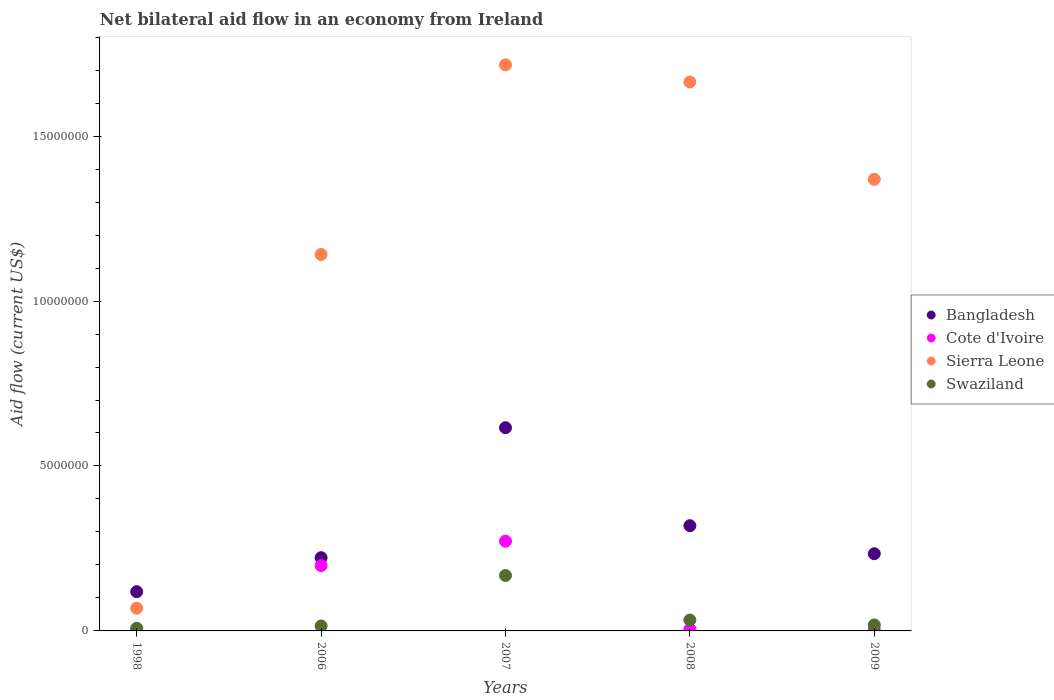Across all years, what is the maximum net bilateral aid flow in Sierra Leone?
Make the answer very short. 1.72e+07. What is the total net bilateral aid flow in Bangladesh in the graph?
Your answer should be very brief. 1.51e+07. What is the difference between the net bilateral aid flow in Swaziland in 2006 and that in 2007?
Your answer should be compact. -1.53e+06. What is the difference between the net bilateral aid flow in Bangladesh in 2007 and the net bilateral aid flow in Swaziland in 2008?
Offer a terse response. 5.83e+06. What is the average net bilateral aid flow in Sierra Leone per year?
Make the answer very short. 1.19e+07. In the year 2009, what is the difference between the net bilateral aid flow in Sierra Leone and net bilateral aid flow in Cote d'Ivoire?
Your answer should be very brief. 1.37e+07. In how many years, is the net bilateral aid flow in Cote d'Ivoire greater than 13000000 US$?
Your response must be concise. 0. What is the ratio of the net bilateral aid flow in Sierra Leone in 2008 to that in 2009?
Your response must be concise. 1.22. Is the difference between the net bilateral aid flow in Sierra Leone in 2007 and 2009 greater than the difference between the net bilateral aid flow in Cote d'Ivoire in 2007 and 2009?
Offer a terse response. Yes. What is the difference between the highest and the second highest net bilateral aid flow in Swaziland?
Your response must be concise. 1.35e+06. What is the difference between the highest and the lowest net bilateral aid flow in Sierra Leone?
Provide a succinct answer. 1.65e+07. In how many years, is the net bilateral aid flow in Bangladesh greater than the average net bilateral aid flow in Bangladesh taken over all years?
Ensure brevity in your answer.  2. Is the net bilateral aid flow in Swaziland strictly greater than the net bilateral aid flow in Bangladesh over the years?
Your answer should be very brief. No. Is the net bilateral aid flow in Sierra Leone strictly less than the net bilateral aid flow in Cote d'Ivoire over the years?
Make the answer very short. No. What is the difference between two consecutive major ticks on the Y-axis?
Make the answer very short. 5.00e+06. Are the values on the major ticks of Y-axis written in scientific E-notation?
Your answer should be compact. No. Does the graph contain grids?
Your response must be concise. No. How many legend labels are there?
Offer a very short reply. 4. How are the legend labels stacked?
Your response must be concise. Vertical. What is the title of the graph?
Provide a succinct answer. Net bilateral aid flow in an economy from Ireland. Does "Bulgaria" appear as one of the legend labels in the graph?
Ensure brevity in your answer.  No. What is the label or title of the Y-axis?
Offer a terse response. Aid flow (current US$). What is the Aid flow (current US$) of Bangladesh in 1998?
Make the answer very short. 1.19e+06. What is the Aid flow (current US$) of Cote d'Ivoire in 1998?
Your answer should be compact. 2.00e+04. What is the Aid flow (current US$) of Sierra Leone in 1998?
Your answer should be very brief. 6.90e+05. What is the Aid flow (current US$) in Bangladesh in 2006?
Your answer should be compact. 2.22e+06. What is the Aid flow (current US$) in Cote d'Ivoire in 2006?
Provide a short and direct response. 1.98e+06. What is the Aid flow (current US$) in Sierra Leone in 2006?
Your answer should be very brief. 1.14e+07. What is the Aid flow (current US$) in Swaziland in 2006?
Provide a short and direct response. 1.50e+05. What is the Aid flow (current US$) in Bangladesh in 2007?
Your answer should be compact. 6.16e+06. What is the Aid flow (current US$) of Cote d'Ivoire in 2007?
Ensure brevity in your answer.  2.72e+06. What is the Aid flow (current US$) in Sierra Leone in 2007?
Offer a very short reply. 1.72e+07. What is the Aid flow (current US$) of Swaziland in 2007?
Ensure brevity in your answer.  1.68e+06. What is the Aid flow (current US$) of Bangladesh in 2008?
Make the answer very short. 3.19e+06. What is the Aid flow (current US$) in Cote d'Ivoire in 2008?
Keep it short and to the point. 5.00e+04. What is the Aid flow (current US$) of Sierra Leone in 2008?
Make the answer very short. 1.66e+07. What is the Aid flow (current US$) of Bangladesh in 2009?
Keep it short and to the point. 2.34e+06. What is the Aid flow (current US$) in Cote d'Ivoire in 2009?
Offer a very short reply. 3.00e+04. What is the Aid flow (current US$) in Sierra Leone in 2009?
Offer a very short reply. 1.37e+07. Across all years, what is the maximum Aid flow (current US$) in Bangladesh?
Provide a succinct answer. 6.16e+06. Across all years, what is the maximum Aid flow (current US$) of Cote d'Ivoire?
Ensure brevity in your answer.  2.72e+06. Across all years, what is the maximum Aid flow (current US$) in Sierra Leone?
Ensure brevity in your answer.  1.72e+07. Across all years, what is the maximum Aid flow (current US$) of Swaziland?
Ensure brevity in your answer.  1.68e+06. Across all years, what is the minimum Aid flow (current US$) of Bangladesh?
Ensure brevity in your answer.  1.19e+06. Across all years, what is the minimum Aid flow (current US$) of Cote d'Ivoire?
Your answer should be very brief. 2.00e+04. Across all years, what is the minimum Aid flow (current US$) in Sierra Leone?
Ensure brevity in your answer.  6.90e+05. Across all years, what is the minimum Aid flow (current US$) in Swaziland?
Your answer should be very brief. 8.00e+04. What is the total Aid flow (current US$) of Bangladesh in the graph?
Your response must be concise. 1.51e+07. What is the total Aid flow (current US$) in Cote d'Ivoire in the graph?
Offer a terse response. 4.80e+06. What is the total Aid flow (current US$) in Sierra Leone in the graph?
Your answer should be compact. 5.96e+07. What is the total Aid flow (current US$) in Swaziland in the graph?
Your response must be concise. 2.42e+06. What is the difference between the Aid flow (current US$) of Bangladesh in 1998 and that in 2006?
Give a very brief answer. -1.03e+06. What is the difference between the Aid flow (current US$) of Cote d'Ivoire in 1998 and that in 2006?
Provide a short and direct response. -1.96e+06. What is the difference between the Aid flow (current US$) of Sierra Leone in 1998 and that in 2006?
Offer a very short reply. -1.07e+07. What is the difference between the Aid flow (current US$) of Bangladesh in 1998 and that in 2007?
Keep it short and to the point. -4.97e+06. What is the difference between the Aid flow (current US$) in Cote d'Ivoire in 1998 and that in 2007?
Ensure brevity in your answer.  -2.70e+06. What is the difference between the Aid flow (current US$) in Sierra Leone in 1998 and that in 2007?
Your response must be concise. -1.65e+07. What is the difference between the Aid flow (current US$) in Swaziland in 1998 and that in 2007?
Your answer should be compact. -1.60e+06. What is the difference between the Aid flow (current US$) of Bangladesh in 1998 and that in 2008?
Ensure brevity in your answer.  -2.00e+06. What is the difference between the Aid flow (current US$) of Sierra Leone in 1998 and that in 2008?
Keep it short and to the point. -1.60e+07. What is the difference between the Aid flow (current US$) in Bangladesh in 1998 and that in 2009?
Make the answer very short. -1.15e+06. What is the difference between the Aid flow (current US$) of Sierra Leone in 1998 and that in 2009?
Make the answer very short. -1.30e+07. What is the difference between the Aid flow (current US$) of Bangladesh in 2006 and that in 2007?
Make the answer very short. -3.94e+06. What is the difference between the Aid flow (current US$) of Cote d'Ivoire in 2006 and that in 2007?
Provide a short and direct response. -7.40e+05. What is the difference between the Aid flow (current US$) in Sierra Leone in 2006 and that in 2007?
Provide a succinct answer. -5.75e+06. What is the difference between the Aid flow (current US$) in Swaziland in 2006 and that in 2007?
Offer a terse response. -1.53e+06. What is the difference between the Aid flow (current US$) of Bangladesh in 2006 and that in 2008?
Offer a very short reply. -9.70e+05. What is the difference between the Aid flow (current US$) of Cote d'Ivoire in 2006 and that in 2008?
Make the answer very short. 1.93e+06. What is the difference between the Aid flow (current US$) in Sierra Leone in 2006 and that in 2008?
Your answer should be compact. -5.23e+06. What is the difference between the Aid flow (current US$) in Cote d'Ivoire in 2006 and that in 2009?
Offer a terse response. 1.95e+06. What is the difference between the Aid flow (current US$) in Sierra Leone in 2006 and that in 2009?
Ensure brevity in your answer.  -2.28e+06. What is the difference between the Aid flow (current US$) of Swaziland in 2006 and that in 2009?
Ensure brevity in your answer.  -3.00e+04. What is the difference between the Aid flow (current US$) of Bangladesh in 2007 and that in 2008?
Your response must be concise. 2.97e+06. What is the difference between the Aid flow (current US$) of Cote d'Ivoire in 2007 and that in 2008?
Provide a short and direct response. 2.67e+06. What is the difference between the Aid flow (current US$) in Sierra Leone in 2007 and that in 2008?
Your answer should be compact. 5.20e+05. What is the difference between the Aid flow (current US$) in Swaziland in 2007 and that in 2008?
Ensure brevity in your answer.  1.35e+06. What is the difference between the Aid flow (current US$) in Bangladesh in 2007 and that in 2009?
Your response must be concise. 3.82e+06. What is the difference between the Aid flow (current US$) of Cote d'Ivoire in 2007 and that in 2009?
Ensure brevity in your answer.  2.69e+06. What is the difference between the Aid flow (current US$) in Sierra Leone in 2007 and that in 2009?
Your answer should be very brief. 3.47e+06. What is the difference between the Aid flow (current US$) of Swaziland in 2007 and that in 2009?
Give a very brief answer. 1.50e+06. What is the difference between the Aid flow (current US$) in Bangladesh in 2008 and that in 2009?
Keep it short and to the point. 8.50e+05. What is the difference between the Aid flow (current US$) in Cote d'Ivoire in 2008 and that in 2009?
Ensure brevity in your answer.  2.00e+04. What is the difference between the Aid flow (current US$) in Sierra Leone in 2008 and that in 2009?
Provide a short and direct response. 2.95e+06. What is the difference between the Aid flow (current US$) in Bangladesh in 1998 and the Aid flow (current US$) in Cote d'Ivoire in 2006?
Provide a short and direct response. -7.90e+05. What is the difference between the Aid flow (current US$) of Bangladesh in 1998 and the Aid flow (current US$) of Sierra Leone in 2006?
Make the answer very short. -1.02e+07. What is the difference between the Aid flow (current US$) in Bangladesh in 1998 and the Aid flow (current US$) in Swaziland in 2006?
Your answer should be compact. 1.04e+06. What is the difference between the Aid flow (current US$) of Cote d'Ivoire in 1998 and the Aid flow (current US$) of Sierra Leone in 2006?
Offer a very short reply. -1.14e+07. What is the difference between the Aid flow (current US$) of Cote d'Ivoire in 1998 and the Aid flow (current US$) of Swaziland in 2006?
Ensure brevity in your answer.  -1.30e+05. What is the difference between the Aid flow (current US$) of Sierra Leone in 1998 and the Aid flow (current US$) of Swaziland in 2006?
Provide a short and direct response. 5.40e+05. What is the difference between the Aid flow (current US$) in Bangladesh in 1998 and the Aid flow (current US$) in Cote d'Ivoire in 2007?
Keep it short and to the point. -1.53e+06. What is the difference between the Aid flow (current US$) in Bangladesh in 1998 and the Aid flow (current US$) in Sierra Leone in 2007?
Give a very brief answer. -1.60e+07. What is the difference between the Aid flow (current US$) in Bangladesh in 1998 and the Aid flow (current US$) in Swaziland in 2007?
Ensure brevity in your answer.  -4.90e+05. What is the difference between the Aid flow (current US$) of Cote d'Ivoire in 1998 and the Aid flow (current US$) of Sierra Leone in 2007?
Your response must be concise. -1.71e+07. What is the difference between the Aid flow (current US$) in Cote d'Ivoire in 1998 and the Aid flow (current US$) in Swaziland in 2007?
Offer a terse response. -1.66e+06. What is the difference between the Aid flow (current US$) of Sierra Leone in 1998 and the Aid flow (current US$) of Swaziland in 2007?
Ensure brevity in your answer.  -9.90e+05. What is the difference between the Aid flow (current US$) in Bangladesh in 1998 and the Aid flow (current US$) in Cote d'Ivoire in 2008?
Offer a terse response. 1.14e+06. What is the difference between the Aid flow (current US$) of Bangladesh in 1998 and the Aid flow (current US$) of Sierra Leone in 2008?
Your response must be concise. -1.54e+07. What is the difference between the Aid flow (current US$) in Bangladesh in 1998 and the Aid flow (current US$) in Swaziland in 2008?
Make the answer very short. 8.60e+05. What is the difference between the Aid flow (current US$) of Cote d'Ivoire in 1998 and the Aid flow (current US$) of Sierra Leone in 2008?
Your response must be concise. -1.66e+07. What is the difference between the Aid flow (current US$) of Cote d'Ivoire in 1998 and the Aid flow (current US$) of Swaziland in 2008?
Your answer should be compact. -3.10e+05. What is the difference between the Aid flow (current US$) in Bangladesh in 1998 and the Aid flow (current US$) in Cote d'Ivoire in 2009?
Make the answer very short. 1.16e+06. What is the difference between the Aid flow (current US$) of Bangladesh in 1998 and the Aid flow (current US$) of Sierra Leone in 2009?
Make the answer very short. -1.25e+07. What is the difference between the Aid flow (current US$) of Bangladesh in 1998 and the Aid flow (current US$) of Swaziland in 2009?
Your answer should be compact. 1.01e+06. What is the difference between the Aid flow (current US$) in Cote d'Ivoire in 1998 and the Aid flow (current US$) in Sierra Leone in 2009?
Offer a very short reply. -1.37e+07. What is the difference between the Aid flow (current US$) of Sierra Leone in 1998 and the Aid flow (current US$) of Swaziland in 2009?
Offer a very short reply. 5.10e+05. What is the difference between the Aid flow (current US$) of Bangladesh in 2006 and the Aid flow (current US$) of Cote d'Ivoire in 2007?
Your response must be concise. -5.00e+05. What is the difference between the Aid flow (current US$) in Bangladesh in 2006 and the Aid flow (current US$) in Sierra Leone in 2007?
Give a very brief answer. -1.49e+07. What is the difference between the Aid flow (current US$) in Bangladesh in 2006 and the Aid flow (current US$) in Swaziland in 2007?
Give a very brief answer. 5.40e+05. What is the difference between the Aid flow (current US$) in Cote d'Ivoire in 2006 and the Aid flow (current US$) in Sierra Leone in 2007?
Provide a succinct answer. -1.52e+07. What is the difference between the Aid flow (current US$) in Sierra Leone in 2006 and the Aid flow (current US$) in Swaziland in 2007?
Provide a succinct answer. 9.73e+06. What is the difference between the Aid flow (current US$) in Bangladesh in 2006 and the Aid flow (current US$) in Cote d'Ivoire in 2008?
Ensure brevity in your answer.  2.17e+06. What is the difference between the Aid flow (current US$) of Bangladesh in 2006 and the Aid flow (current US$) of Sierra Leone in 2008?
Your response must be concise. -1.44e+07. What is the difference between the Aid flow (current US$) of Bangladesh in 2006 and the Aid flow (current US$) of Swaziland in 2008?
Give a very brief answer. 1.89e+06. What is the difference between the Aid flow (current US$) in Cote d'Ivoire in 2006 and the Aid flow (current US$) in Sierra Leone in 2008?
Offer a very short reply. -1.47e+07. What is the difference between the Aid flow (current US$) in Cote d'Ivoire in 2006 and the Aid flow (current US$) in Swaziland in 2008?
Provide a succinct answer. 1.65e+06. What is the difference between the Aid flow (current US$) in Sierra Leone in 2006 and the Aid flow (current US$) in Swaziland in 2008?
Make the answer very short. 1.11e+07. What is the difference between the Aid flow (current US$) in Bangladesh in 2006 and the Aid flow (current US$) in Cote d'Ivoire in 2009?
Ensure brevity in your answer.  2.19e+06. What is the difference between the Aid flow (current US$) of Bangladesh in 2006 and the Aid flow (current US$) of Sierra Leone in 2009?
Your answer should be compact. -1.15e+07. What is the difference between the Aid flow (current US$) in Bangladesh in 2006 and the Aid flow (current US$) in Swaziland in 2009?
Provide a short and direct response. 2.04e+06. What is the difference between the Aid flow (current US$) of Cote d'Ivoire in 2006 and the Aid flow (current US$) of Sierra Leone in 2009?
Provide a short and direct response. -1.17e+07. What is the difference between the Aid flow (current US$) in Cote d'Ivoire in 2006 and the Aid flow (current US$) in Swaziland in 2009?
Ensure brevity in your answer.  1.80e+06. What is the difference between the Aid flow (current US$) of Sierra Leone in 2006 and the Aid flow (current US$) of Swaziland in 2009?
Make the answer very short. 1.12e+07. What is the difference between the Aid flow (current US$) in Bangladesh in 2007 and the Aid flow (current US$) in Cote d'Ivoire in 2008?
Your response must be concise. 6.11e+06. What is the difference between the Aid flow (current US$) in Bangladesh in 2007 and the Aid flow (current US$) in Sierra Leone in 2008?
Offer a terse response. -1.05e+07. What is the difference between the Aid flow (current US$) in Bangladesh in 2007 and the Aid flow (current US$) in Swaziland in 2008?
Provide a short and direct response. 5.83e+06. What is the difference between the Aid flow (current US$) of Cote d'Ivoire in 2007 and the Aid flow (current US$) of Sierra Leone in 2008?
Keep it short and to the point. -1.39e+07. What is the difference between the Aid flow (current US$) of Cote d'Ivoire in 2007 and the Aid flow (current US$) of Swaziland in 2008?
Keep it short and to the point. 2.39e+06. What is the difference between the Aid flow (current US$) in Sierra Leone in 2007 and the Aid flow (current US$) in Swaziland in 2008?
Your response must be concise. 1.68e+07. What is the difference between the Aid flow (current US$) in Bangladesh in 2007 and the Aid flow (current US$) in Cote d'Ivoire in 2009?
Offer a very short reply. 6.13e+06. What is the difference between the Aid flow (current US$) in Bangladesh in 2007 and the Aid flow (current US$) in Sierra Leone in 2009?
Your response must be concise. -7.53e+06. What is the difference between the Aid flow (current US$) in Bangladesh in 2007 and the Aid flow (current US$) in Swaziland in 2009?
Ensure brevity in your answer.  5.98e+06. What is the difference between the Aid flow (current US$) in Cote d'Ivoire in 2007 and the Aid flow (current US$) in Sierra Leone in 2009?
Your answer should be compact. -1.10e+07. What is the difference between the Aid flow (current US$) of Cote d'Ivoire in 2007 and the Aid flow (current US$) of Swaziland in 2009?
Give a very brief answer. 2.54e+06. What is the difference between the Aid flow (current US$) in Sierra Leone in 2007 and the Aid flow (current US$) in Swaziland in 2009?
Keep it short and to the point. 1.70e+07. What is the difference between the Aid flow (current US$) in Bangladesh in 2008 and the Aid flow (current US$) in Cote d'Ivoire in 2009?
Provide a succinct answer. 3.16e+06. What is the difference between the Aid flow (current US$) in Bangladesh in 2008 and the Aid flow (current US$) in Sierra Leone in 2009?
Offer a very short reply. -1.05e+07. What is the difference between the Aid flow (current US$) in Bangladesh in 2008 and the Aid flow (current US$) in Swaziland in 2009?
Keep it short and to the point. 3.01e+06. What is the difference between the Aid flow (current US$) of Cote d'Ivoire in 2008 and the Aid flow (current US$) of Sierra Leone in 2009?
Your answer should be compact. -1.36e+07. What is the difference between the Aid flow (current US$) of Sierra Leone in 2008 and the Aid flow (current US$) of Swaziland in 2009?
Ensure brevity in your answer.  1.65e+07. What is the average Aid flow (current US$) in Bangladesh per year?
Give a very brief answer. 3.02e+06. What is the average Aid flow (current US$) of Cote d'Ivoire per year?
Keep it short and to the point. 9.60e+05. What is the average Aid flow (current US$) of Sierra Leone per year?
Offer a terse response. 1.19e+07. What is the average Aid flow (current US$) in Swaziland per year?
Your answer should be very brief. 4.84e+05. In the year 1998, what is the difference between the Aid flow (current US$) in Bangladesh and Aid flow (current US$) in Cote d'Ivoire?
Your answer should be compact. 1.17e+06. In the year 1998, what is the difference between the Aid flow (current US$) of Bangladesh and Aid flow (current US$) of Sierra Leone?
Give a very brief answer. 5.00e+05. In the year 1998, what is the difference between the Aid flow (current US$) in Bangladesh and Aid flow (current US$) in Swaziland?
Provide a short and direct response. 1.11e+06. In the year 1998, what is the difference between the Aid flow (current US$) of Cote d'Ivoire and Aid flow (current US$) of Sierra Leone?
Offer a terse response. -6.70e+05. In the year 2006, what is the difference between the Aid flow (current US$) of Bangladesh and Aid flow (current US$) of Cote d'Ivoire?
Make the answer very short. 2.40e+05. In the year 2006, what is the difference between the Aid flow (current US$) of Bangladesh and Aid flow (current US$) of Sierra Leone?
Provide a short and direct response. -9.19e+06. In the year 2006, what is the difference between the Aid flow (current US$) in Bangladesh and Aid flow (current US$) in Swaziland?
Offer a very short reply. 2.07e+06. In the year 2006, what is the difference between the Aid flow (current US$) in Cote d'Ivoire and Aid flow (current US$) in Sierra Leone?
Give a very brief answer. -9.43e+06. In the year 2006, what is the difference between the Aid flow (current US$) in Cote d'Ivoire and Aid flow (current US$) in Swaziland?
Your answer should be compact. 1.83e+06. In the year 2006, what is the difference between the Aid flow (current US$) of Sierra Leone and Aid flow (current US$) of Swaziland?
Make the answer very short. 1.13e+07. In the year 2007, what is the difference between the Aid flow (current US$) in Bangladesh and Aid flow (current US$) in Cote d'Ivoire?
Your answer should be compact. 3.44e+06. In the year 2007, what is the difference between the Aid flow (current US$) of Bangladesh and Aid flow (current US$) of Sierra Leone?
Make the answer very short. -1.10e+07. In the year 2007, what is the difference between the Aid flow (current US$) in Bangladesh and Aid flow (current US$) in Swaziland?
Make the answer very short. 4.48e+06. In the year 2007, what is the difference between the Aid flow (current US$) in Cote d'Ivoire and Aid flow (current US$) in Sierra Leone?
Your answer should be very brief. -1.44e+07. In the year 2007, what is the difference between the Aid flow (current US$) in Cote d'Ivoire and Aid flow (current US$) in Swaziland?
Give a very brief answer. 1.04e+06. In the year 2007, what is the difference between the Aid flow (current US$) in Sierra Leone and Aid flow (current US$) in Swaziland?
Offer a terse response. 1.55e+07. In the year 2008, what is the difference between the Aid flow (current US$) in Bangladesh and Aid flow (current US$) in Cote d'Ivoire?
Keep it short and to the point. 3.14e+06. In the year 2008, what is the difference between the Aid flow (current US$) in Bangladesh and Aid flow (current US$) in Sierra Leone?
Offer a very short reply. -1.34e+07. In the year 2008, what is the difference between the Aid flow (current US$) in Bangladesh and Aid flow (current US$) in Swaziland?
Your answer should be compact. 2.86e+06. In the year 2008, what is the difference between the Aid flow (current US$) of Cote d'Ivoire and Aid flow (current US$) of Sierra Leone?
Provide a short and direct response. -1.66e+07. In the year 2008, what is the difference between the Aid flow (current US$) of Cote d'Ivoire and Aid flow (current US$) of Swaziland?
Offer a terse response. -2.80e+05. In the year 2008, what is the difference between the Aid flow (current US$) in Sierra Leone and Aid flow (current US$) in Swaziland?
Ensure brevity in your answer.  1.63e+07. In the year 2009, what is the difference between the Aid flow (current US$) in Bangladesh and Aid flow (current US$) in Cote d'Ivoire?
Ensure brevity in your answer.  2.31e+06. In the year 2009, what is the difference between the Aid flow (current US$) of Bangladesh and Aid flow (current US$) of Sierra Leone?
Your answer should be very brief. -1.14e+07. In the year 2009, what is the difference between the Aid flow (current US$) of Bangladesh and Aid flow (current US$) of Swaziland?
Provide a short and direct response. 2.16e+06. In the year 2009, what is the difference between the Aid flow (current US$) of Cote d'Ivoire and Aid flow (current US$) of Sierra Leone?
Provide a short and direct response. -1.37e+07. In the year 2009, what is the difference between the Aid flow (current US$) in Cote d'Ivoire and Aid flow (current US$) in Swaziland?
Make the answer very short. -1.50e+05. In the year 2009, what is the difference between the Aid flow (current US$) of Sierra Leone and Aid flow (current US$) of Swaziland?
Your answer should be compact. 1.35e+07. What is the ratio of the Aid flow (current US$) of Bangladesh in 1998 to that in 2006?
Keep it short and to the point. 0.54. What is the ratio of the Aid flow (current US$) of Cote d'Ivoire in 1998 to that in 2006?
Give a very brief answer. 0.01. What is the ratio of the Aid flow (current US$) of Sierra Leone in 1998 to that in 2006?
Your answer should be very brief. 0.06. What is the ratio of the Aid flow (current US$) of Swaziland in 1998 to that in 2006?
Your response must be concise. 0.53. What is the ratio of the Aid flow (current US$) of Bangladesh in 1998 to that in 2007?
Make the answer very short. 0.19. What is the ratio of the Aid flow (current US$) of Cote d'Ivoire in 1998 to that in 2007?
Give a very brief answer. 0.01. What is the ratio of the Aid flow (current US$) in Sierra Leone in 1998 to that in 2007?
Provide a short and direct response. 0.04. What is the ratio of the Aid flow (current US$) of Swaziland in 1998 to that in 2007?
Keep it short and to the point. 0.05. What is the ratio of the Aid flow (current US$) of Bangladesh in 1998 to that in 2008?
Offer a very short reply. 0.37. What is the ratio of the Aid flow (current US$) in Cote d'Ivoire in 1998 to that in 2008?
Keep it short and to the point. 0.4. What is the ratio of the Aid flow (current US$) of Sierra Leone in 1998 to that in 2008?
Keep it short and to the point. 0.04. What is the ratio of the Aid flow (current US$) in Swaziland in 1998 to that in 2008?
Provide a short and direct response. 0.24. What is the ratio of the Aid flow (current US$) in Bangladesh in 1998 to that in 2009?
Offer a terse response. 0.51. What is the ratio of the Aid flow (current US$) of Cote d'Ivoire in 1998 to that in 2009?
Keep it short and to the point. 0.67. What is the ratio of the Aid flow (current US$) of Sierra Leone in 1998 to that in 2009?
Your answer should be compact. 0.05. What is the ratio of the Aid flow (current US$) of Swaziland in 1998 to that in 2009?
Make the answer very short. 0.44. What is the ratio of the Aid flow (current US$) in Bangladesh in 2006 to that in 2007?
Offer a very short reply. 0.36. What is the ratio of the Aid flow (current US$) of Cote d'Ivoire in 2006 to that in 2007?
Provide a short and direct response. 0.73. What is the ratio of the Aid flow (current US$) in Sierra Leone in 2006 to that in 2007?
Provide a short and direct response. 0.66. What is the ratio of the Aid flow (current US$) in Swaziland in 2006 to that in 2007?
Ensure brevity in your answer.  0.09. What is the ratio of the Aid flow (current US$) of Bangladesh in 2006 to that in 2008?
Offer a terse response. 0.7. What is the ratio of the Aid flow (current US$) of Cote d'Ivoire in 2006 to that in 2008?
Provide a short and direct response. 39.6. What is the ratio of the Aid flow (current US$) of Sierra Leone in 2006 to that in 2008?
Your answer should be very brief. 0.69. What is the ratio of the Aid flow (current US$) of Swaziland in 2006 to that in 2008?
Give a very brief answer. 0.45. What is the ratio of the Aid flow (current US$) of Bangladesh in 2006 to that in 2009?
Make the answer very short. 0.95. What is the ratio of the Aid flow (current US$) of Sierra Leone in 2006 to that in 2009?
Provide a succinct answer. 0.83. What is the ratio of the Aid flow (current US$) of Swaziland in 2006 to that in 2009?
Your answer should be compact. 0.83. What is the ratio of the Aid flow (current US$) of Bangladesh in 2007 to that in 2008?
Give a very brief answer. 1.93. What is the ratio of the Aid flow (current US$) in Cote d'Ivoire in 2007 to that in 2008?
Keep it short and to the point. 54.4. What is the ratio of the Aid flow (current US$) in Sierra Leone in 2007 to that in 2008?
Your answer should be very brief. 1.03. What is the ratio of the Aid flow (current US$) in Swaziland in 2007 to that in 2008?
Make the answer very short. 5.09. What is the ratio of the Aid flow (current US$) of Bangladesh in 2007 to that in 2009?
Your response must be concise. 2.63. What is the ratio of the Aid flow (current US$) of Cote d'Ivoire in 2007 to that in 2009?
Offer a very short reply. 90.67. What is the ratio of the Aid flow (current US$) of Sierra Leone in 2007 to that in 2009?
Offer a very short reply. 1.25. What is the ratio of the Aid flow (current US$) in Swaziland in 2007 to that in 2009?
Give a very brief answer. 9.33. What is the ratio of the Aid flow (current US$) in Bangladesh in 2008 to that in 2009?
Your answer should be compact. 1.36. What is the ratio of the Aid flow (current US$) in Sierra Leone in 2008 to that in 2009?
Your answer should be compact. 1.22. What is the ratio of the Aid flow (current US$) in Swaziland in 2008 to that in 2009?
Provide a short and direct response. 1.83. What is the difference between the highest and the second highest Aid flow (current US$) in Bangladesh?
Your answer should be very brief. 2.97e+06. What is the difference between the highest and the second highest Aid flow (current US$) in Cote d'Ivoire?
Your response must be concise. 7.40e+05. What is the difference between the highest and the second highest Aid flow (current US$) of Sierra Leone?
Offer a terse response. 5.20e+05. What is the difference between the highest and the second highest Aid flow (current US$) of Swaziland?
Provide a short and direct response. 1.35e+06. What is the difference between the highest and the lowest Aid flow (current US$) in Bangladesh?
Give a very brief answer. 4.97e+06. What is the difference between the highest and the lowest Aid flow (current US$) of Cote d'Ivoire?
Provide a succinct answer. 2.70e+06. What is the difference between the highest and the lowest Aid flow (current US$) in Sierra Leone?
Make the answer very short. 1.65e+07. What is the difference between the highest and the lowest Aid flow (current US$) in Swaziland?
Give a very brief answer. 1.60e+06. 